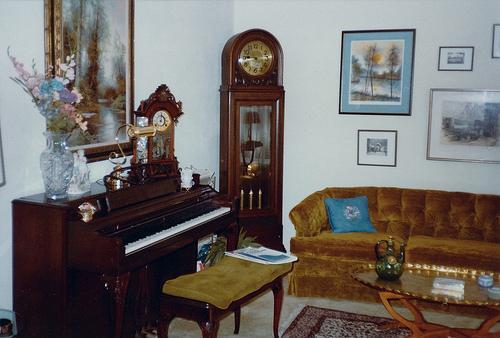How many clocks are there in the picture?
Give a very brief answer. 2. 